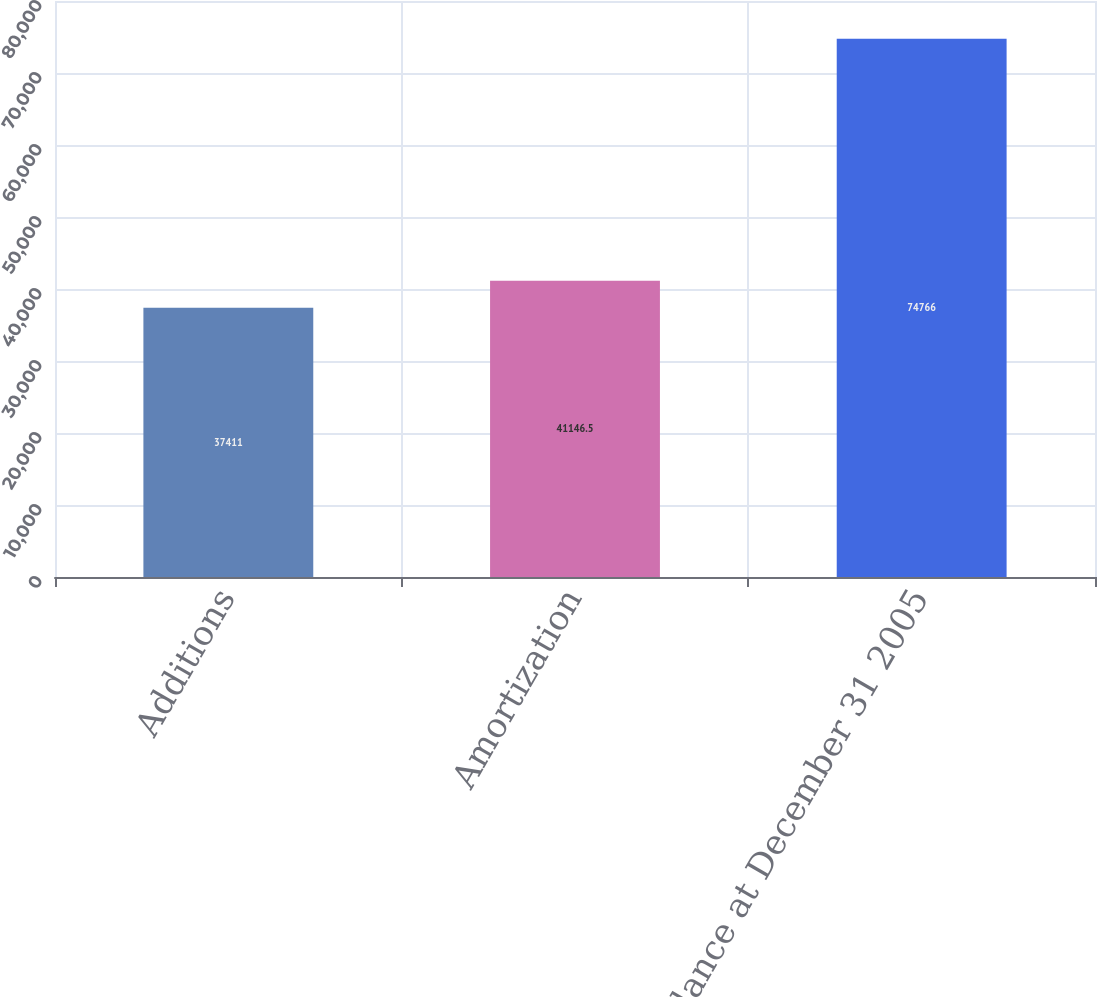Convert chart. <chart><loc_0><loc_0><loc_500><loc_500><bar_chart><fcel>Additions<fcel>Amortization<fcel>Balance at December 31 2005<nl><fcel>37411<fcel>41146.5<fcel>74766<nl></chart> 